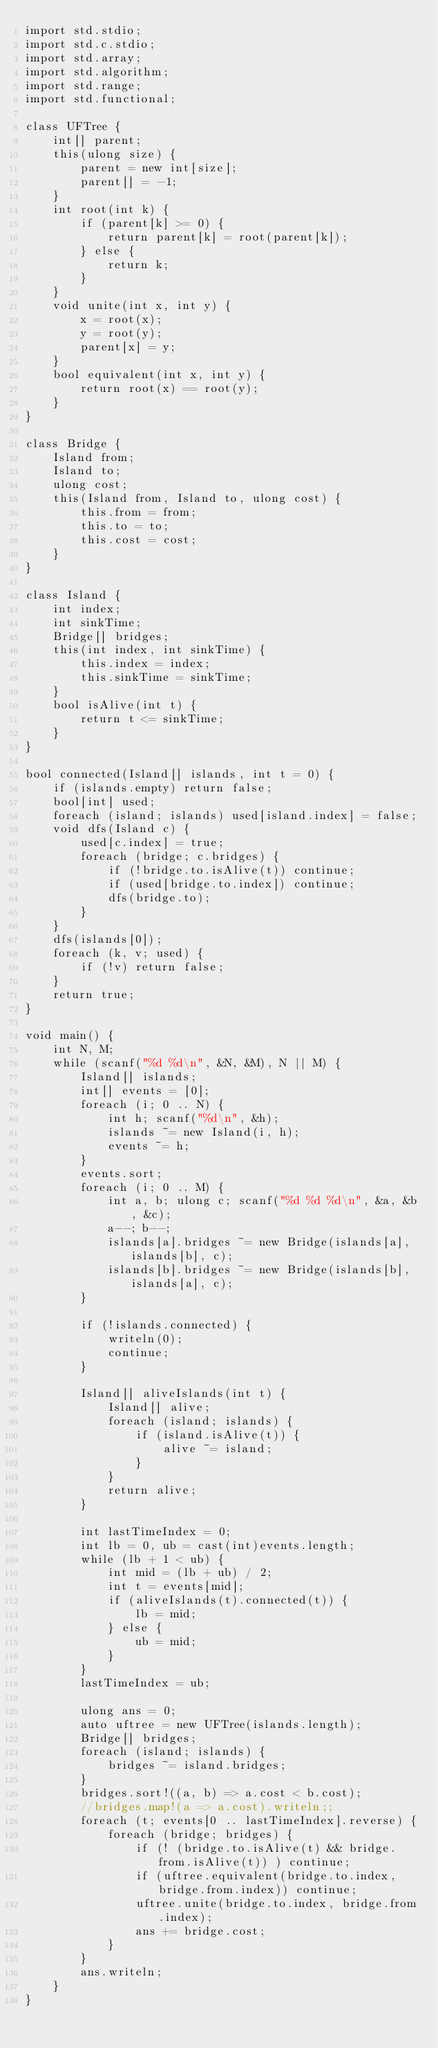Convert code to text. <code><loc_0><loc_0><loc_500><loc_500><_D_>import std.stdio;
import std.c.stdio;
import std.array;
import std.algorithm;
import std.range;
import std.functional;

class UFTree {
    int[] parent;
    this(ulong size) {
        parent = new int[size];
        parent[] = -1;
    }
    int root(int k) {
        if (parent[k] >= 0) {
            return parent[k] = root(parent[k]);
        } else {
            return k;
        }
    }
    void unite(int x, int y) {
        x = root(x);
        y = root(y);
        parent[x] = y;
    }
    bool equivalent(int x, int y) {
        return root(x) == root(y);
    }
}

class Bridge {
    Island from;
    Island to;
    ulong cost;
    this(Island from, Island to, ulong cost) {
        this.from = from;
        this.to = to;
        this.cost = cost;
    }
}

class Island {
    int index;
    int sinkTime;
    Bridge[] bridges;
    this(int index, int sinkTime) {
        this.index = index;
        this.sinkTime = sinkTime;
    }
    bool isAlive(int t) {
        return t <= sinkTime;
    }
}

bool connected(Island[] islands, int t = 0) {
    if (islands.empty) return false;
    bool[int] used;
    foreach (island; islands) used[island.index] = false;
    void dfs(Island c) {
        used[c.index] = true;
        foreach (bridge; c.bridges) {
            if (!bridge.to.isAlive(t)) continue;
            if (used[bridge.to.index]) continue;
            dfs(bridge.to);
        }
    }
    dfs(islands[0]);
    foreach (k, v; used) {
        if (!v) return false;
    }
    return true;
}

void main() {
    int N, M;
    while (scanf("%d %d\n", &N, &M), N || M) {
        Island[] islands;
        int[] events = [0];
        foreach (i; 0 .. N) {
            int h; scanf("%d\n", &h);
            islands ~= new Island(i, h);
            events ~= h;
        }
        events.sort;
        foreach (i; 0 .. M) {
            int a, b; ulong c; scanf("%d %d %d\n", &a, &b, &c);
            a--; b--;
            islands[a].bridges ~= new Bridge(islands[a], islands[b], c); 
            islands[b].bridges ~= new Bridge(islands[b], islands[a], c);
        }

        if (!islands.connected) {
            writeln(0);
            continue;
        }

        Island[] aliveIslands(int t) {
            Island[] alive;
            foreach (island; islands) {
                if (island.isAlive(t)) {
                    alive ~= island;
                }
            }
            return alive;
        }

        int lastTimeIndex = 0;
        int lb = 0, ub = cast(int)events.length;
        while (lb + 1 < ub) {
            int mid = (lb + ub) / 2;
            int t = events[mid];
            if (aliveIslands(t).connected(t)) {
                lb = mid;
            } else {
                ub = mid;
            }
        }
        lastTimeIndex = ub;

        ulong ans = 0;
        auto uftree = new UFTree(islands.length);
        Bridge[] bridges;
        foreach (island; islands) {
            bridges ~= island.bridges;
        }
        bridges.sort!((a, b) => a.cost < b.cost);
        //bridges.map!(a => a.cost).writeln;;
        foreach (t; events[0 .. lastTimeIndex].reverse) {
            foreach (bridge; bridges) {
                if (! (bridge.to.isAlive(t) && bridge.from.isAlive(t)) ) continue;
                if (uftree.equivalent(bridge.to.index, bridge.from.index)) continue;
                uftree.unite(bridge.to.index, bridge.from.index);
                ans += bridge.cost;
            }
        }
        ans.writeln;
    }
}</code> 